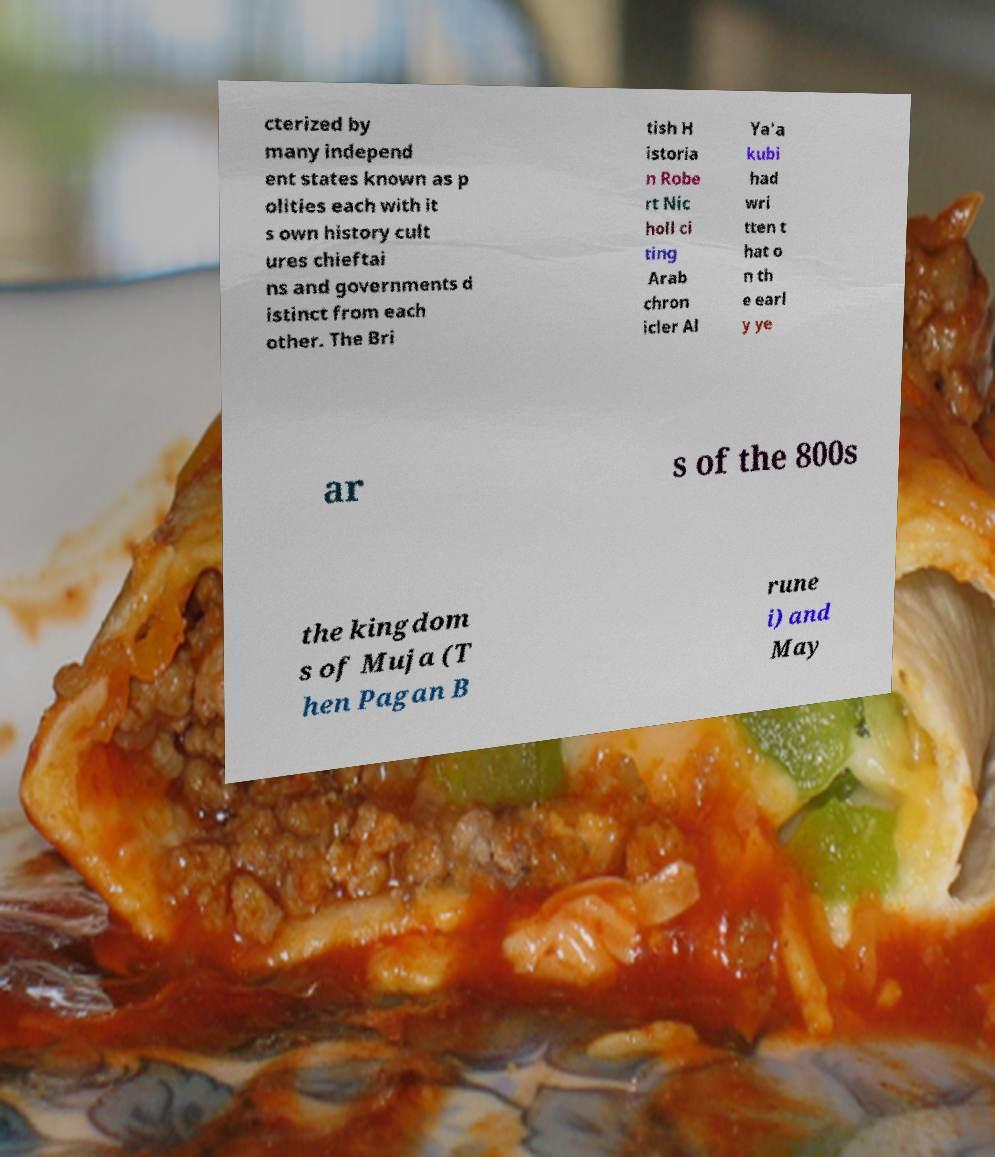What messages or text are displayed in this image? I need them in a readable, typed format. cterized by many independ ent states known as p olities each with it s own history cult ures chieftai ns and governments d istinct from each other. The Bri tish H istoria n Robe rt Nic holl ci ting Arab chron icler Al Ya'a kubi had wri tten t hat o n th e earl y ye ar s of the 800s the kingdom s of Muja (T hen Pagan B rune i) and May 